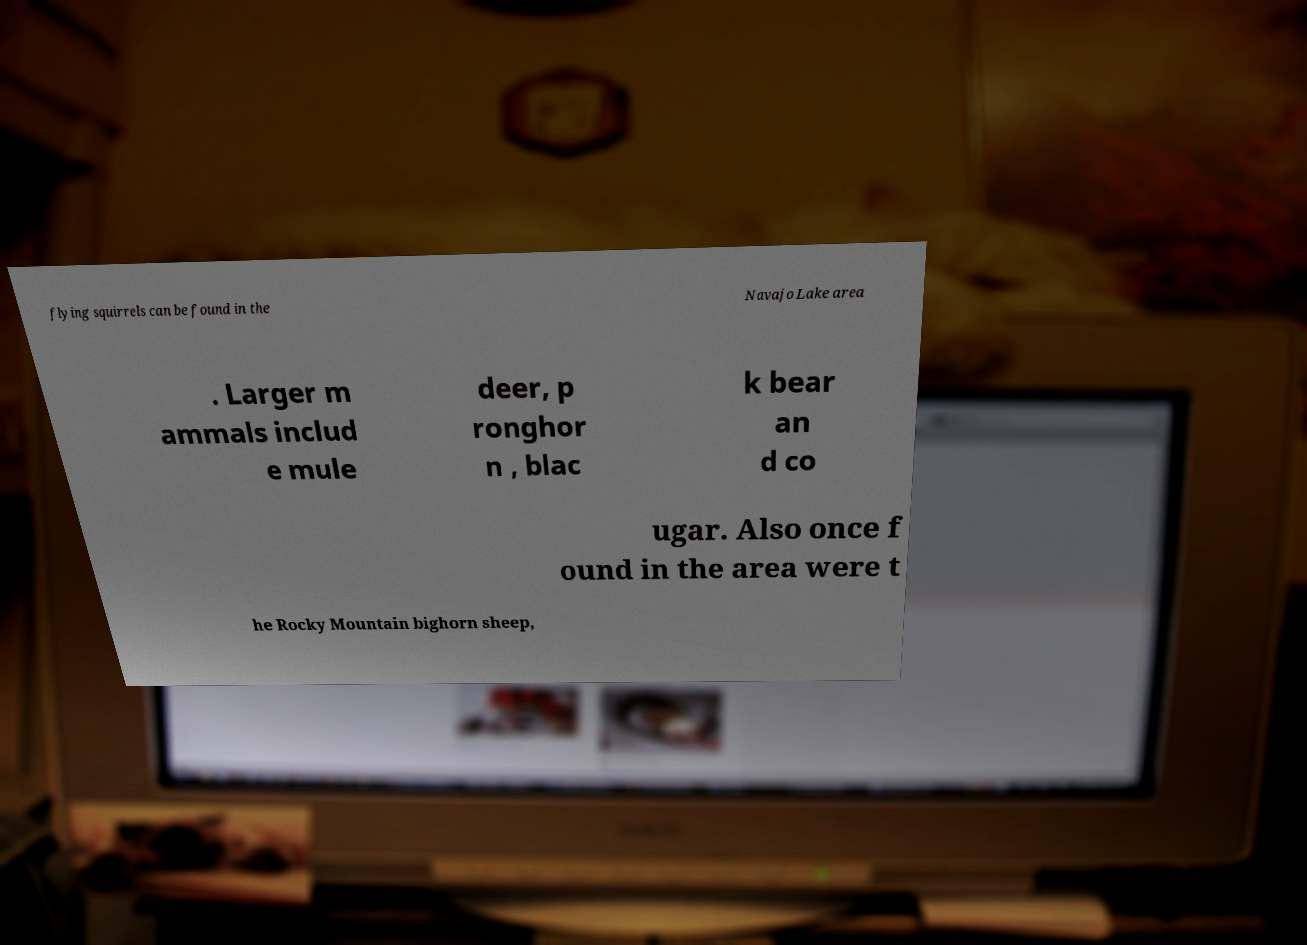There's text embedded in this image that I need extracted. Can you transcribe it verbatim? flying squirrels can be found in the Navajo Lake area . Larger m ammals includ e mule deer, p ronghor n , blac k bear an d co ugar. Also once f ound in the area were t he Rocky Mountain bighorn sheep, 